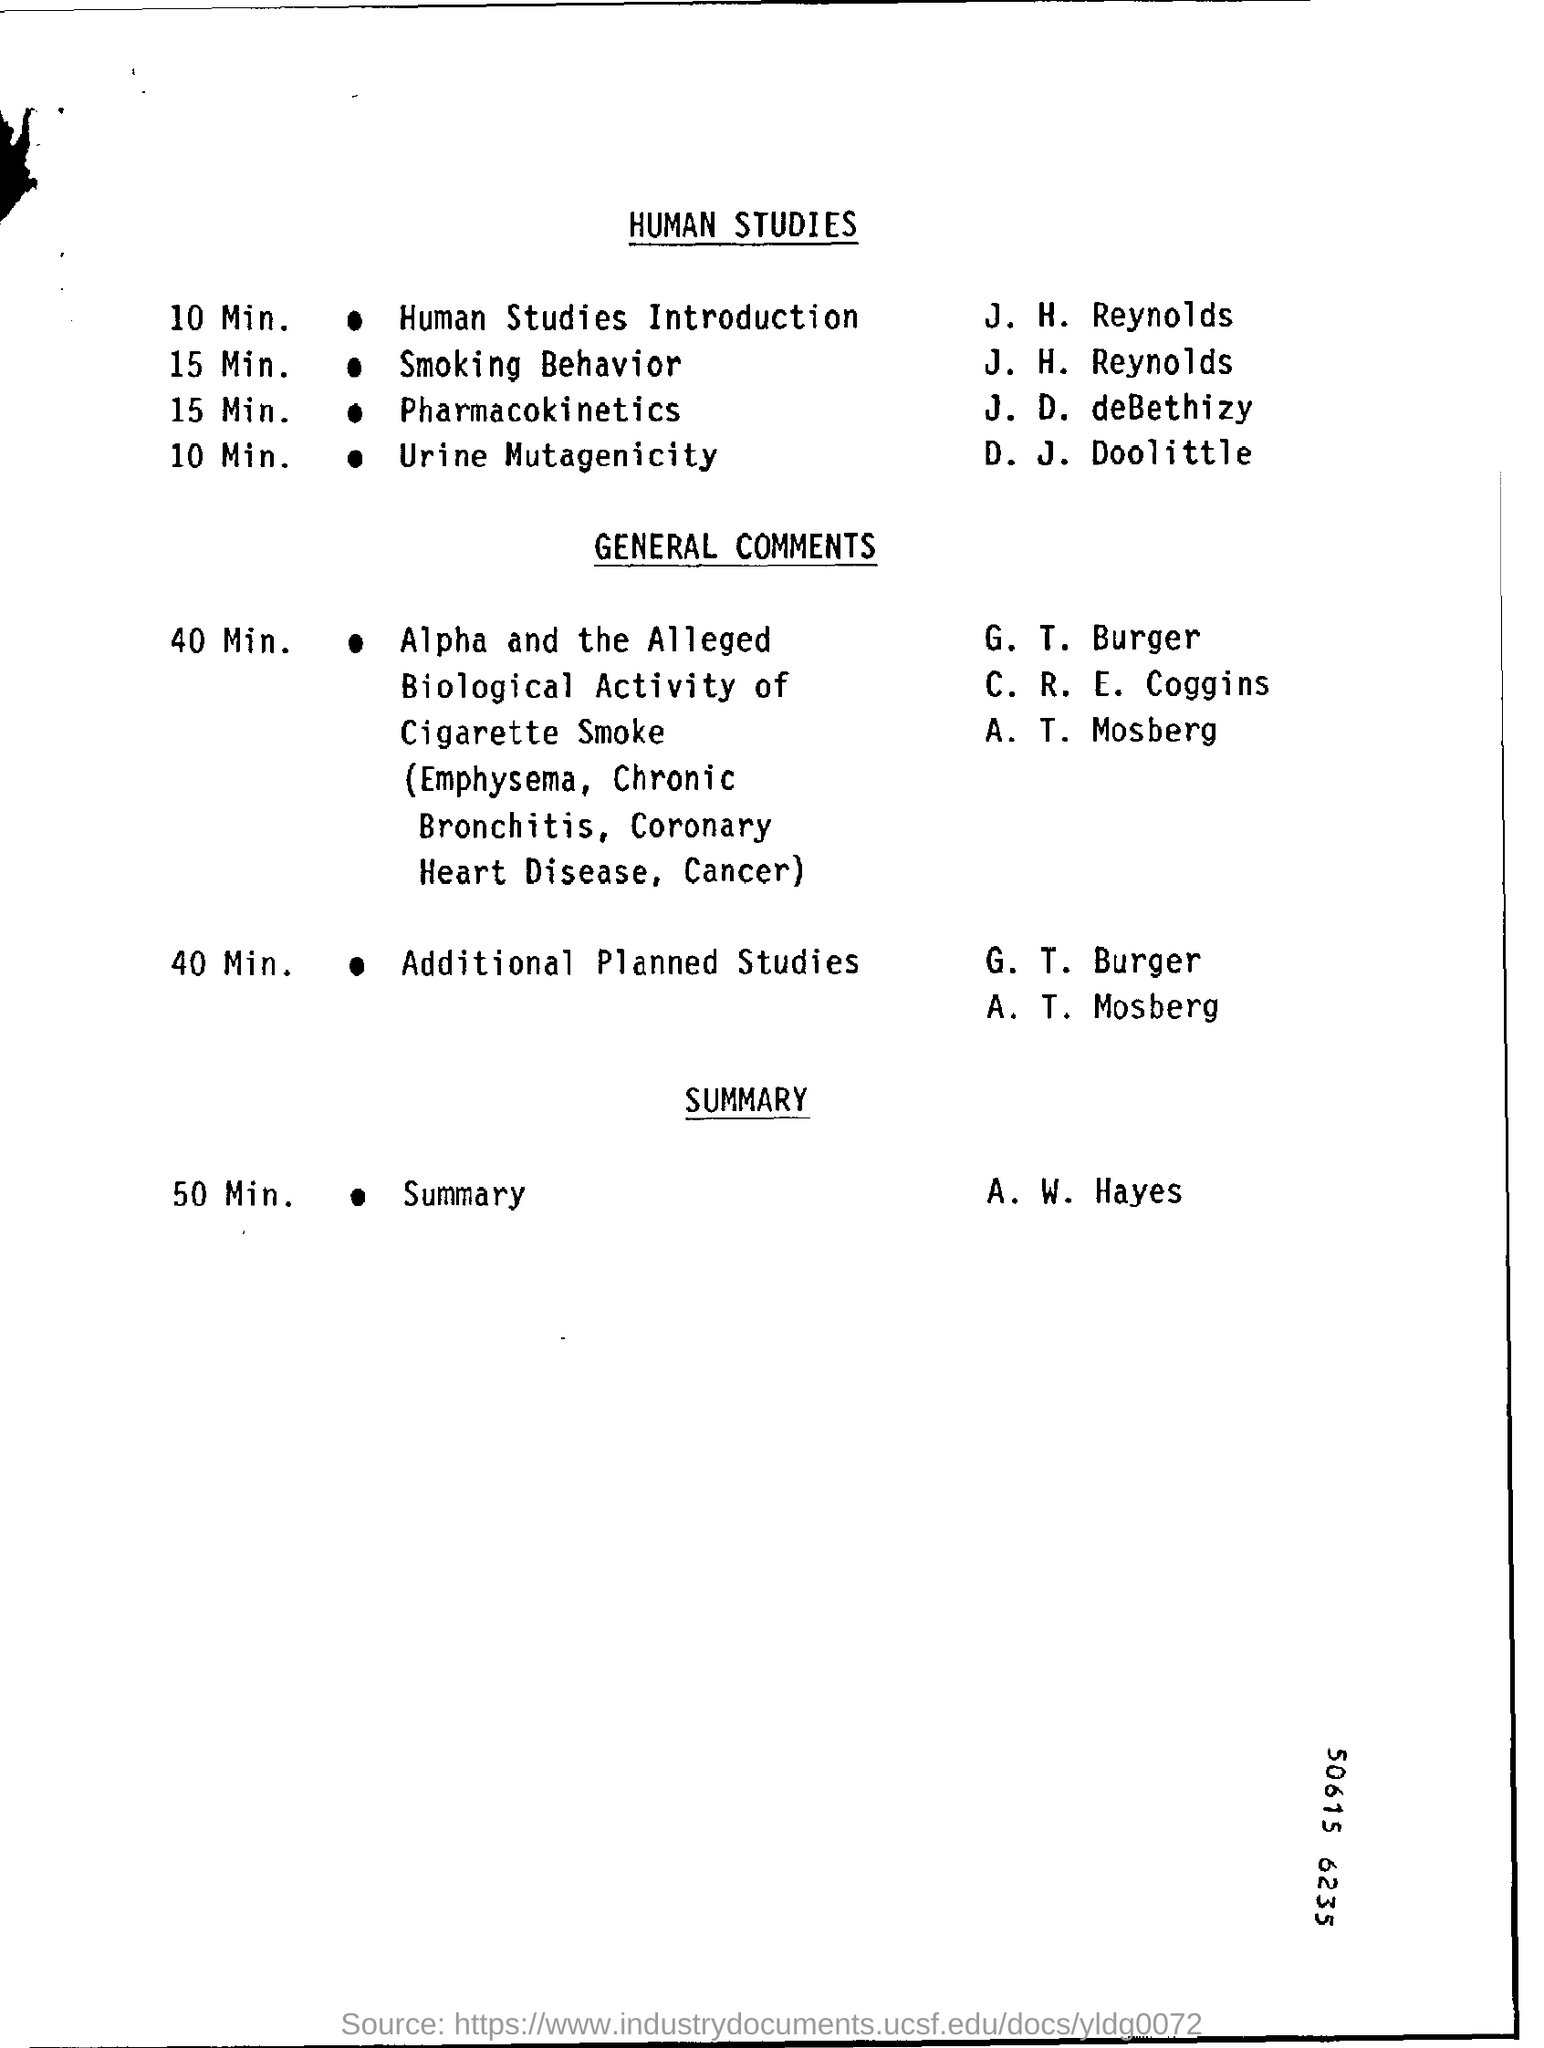Indicate a few pertinent items in this graphic. The duration for human studies introductions is 10 minutes. The summary will be presented by A.W. Hayes. It has been declared that J. H. Reynolds will present the introduction to human studies. D. J. Doolittle will be explaining the topic of urine mutagenicity. 